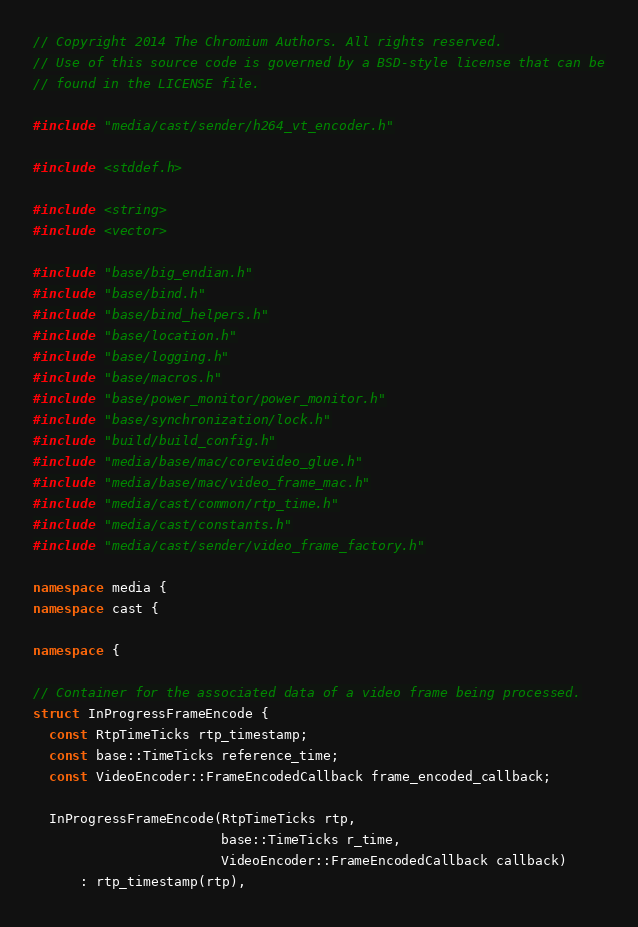<code> <loc_0><loc_0><loc_500><loc_500><_C++_>// Copyright 2014 The Chromium Authors. All rights reserved.
// Use of this source code is governed by a BSD-style license that can be
// found in the LICENSE file.

#include "media/cast/sender/h264_vt_encoder.h"

#include <stddef.h>

#include <string>
#include <vector>

#include "base/big_endian.h"
#include "base/bind.h"
#include "base/bind_helpers.h"
#include "base/location.h"
#include "base/logging.h"
#include "base/macros.h"
#include "base/power_monitor/power_monitor.h"
#include "base/synchronization/lock.h"
#include "build/build_config.h"
#include "media/base/mac/corevideo_glue.h"
#include "media/base/mac/video_frame_mac.h"
#include "media/cast/common/rtp_time.h"
#include "media/cast/constants.h"
#include "media/cast/sender/video_frame_factory.h"

namespace media {
namespace cast {

namespace {

// Container for the associated data of a video frame being processed.
struct InProgressFrameEncode {
  const RtpTimeTicks rtp_timestamp;
  const base::TimeTicks reference_time;
  const VideoEncoder::FrameEncodedCallback frame_encoded_callback;

  InProgressFrameEncode(RtpTimeTicks rtp,
                        base::TimeTicks r_time,
                        VideoEncoder::FrameEncodedCallback callback)
      : rtp_timestamp(rtp),</code> 